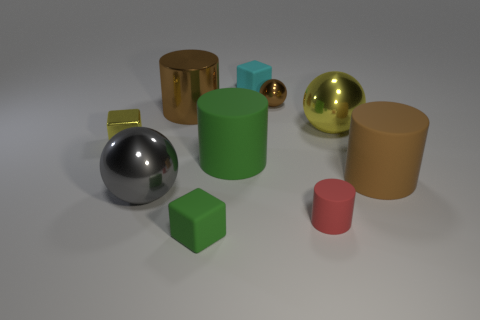Is the number of tiny cyan blocks that are on the left side of the brown metallic cylinder less than the number of large green rubber cubes?
Give a very brief answer. No. There is a metal thing that is in front of the large rubber object that is left of the brown cylinder to the right of the brown metallic cylinder; what color is it?
Make the answer very short. Gray. There is a brown metal thing that is the same shape as the big green matte object; what size is it?
Your response must be concise. Large. Is the number of matte things on the right side of the small red cylinder less than the number of rubber things that are in front of the metallic block?
Offer a very short reply. Yes. There is a big metallic thing that is both behind the big gray thing and in front of the big metal cylinder; what is its shape?
Offer a terse response. Sphere. What size is the yellow ball that is made of the same material as the large gray sphere?
Your answer should be compact. Large. There is a shiny cylinder; is its color the same as the matte cylinder that is to the right of the red matte cylinder?
Ensure brevity in your answer.  Yes. The large thing that is right of the small red thing and behind the tiny yellow metallic thing is made of what material?
Ensure brevity in your answer.  Metal. The metal ball that is the same color as the metallic cylinder is what size?
Offer a terse response. Small. Do the green object in front of the large gray object and the brown object on the left side of the small shiny ball have the same shape?
Ensure brevity in your answer.  No. 